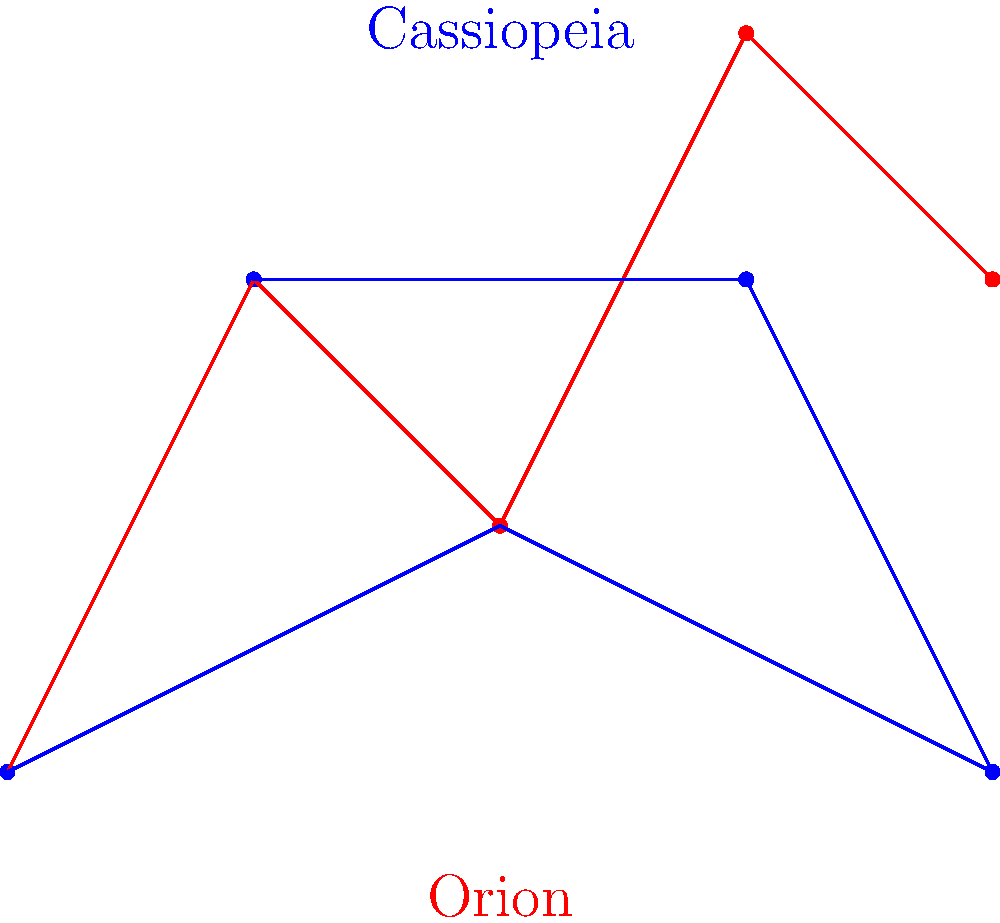Consider the constellation patterns of Orion (red) and Cassiopeia (blue) shown above. Are these two constellations isomorphic as graphs? If so, provide a bijective function $f$ that demonstrates the isomorphism. If not, explain why. To determine if the constellations are isomorphic, we need to check if there exists a bijective function that preserves the adjacency relationships between the vertices.

Step 1: Count vertices and edges
Both constellations have 5 vertices and 4 edges.

Step 2: Check degree sequences
Both constellations have the following degree sequence: (2, 2, 2, 1, 1)

Step 3: Attempt to construct a bijective function
Let's label the vertices of Orion as $O_1, O_2, O_3, O_4, O_5$ from left to right, and Cassiopeia as $C_1, C_2, C_3, C_4, C_5$ from left to right.

We can define a bijective function $f$ as follows:
$f(O_1) = C_1$
$f(O_2) = C_4$
$f(O_3) = C_2$
$f(O_4) = C_3$
$f(O_5) = C_5$

Step 4: Verify that $f$ preserves adjacency
- $O_1$ is adjacent to $O_2$, and $f(O_1) = C_1$ is adjacent to $f(O_2) = C_4$
- $O_2$ is adjacent to $O_3$, and $f(O_2) = C_4$ is adjacent to $f(O_3) = C_2$
- $O_3$ is adjacent to $O_4$, and $f(O_3) = C_2$ is adjacent to $f(O_4) = C_3$
- $O_4$ is adjacent to $O_5$, and $f(O_4) = C_3$ is adjacent to $f(O_5) = C_5$

The function $f$ preserves all adjacency relationships, and it is bijective.

Therefore, the constellations Orion and Cassiopeia are isomorphic as graphs.
Answer: Yes, isomorphic. $f(O_1)=C_1, f(O_2)=C_4, f(O_3)=C_2, f(O_4)=C_3, f(O_5)=C_5$ 